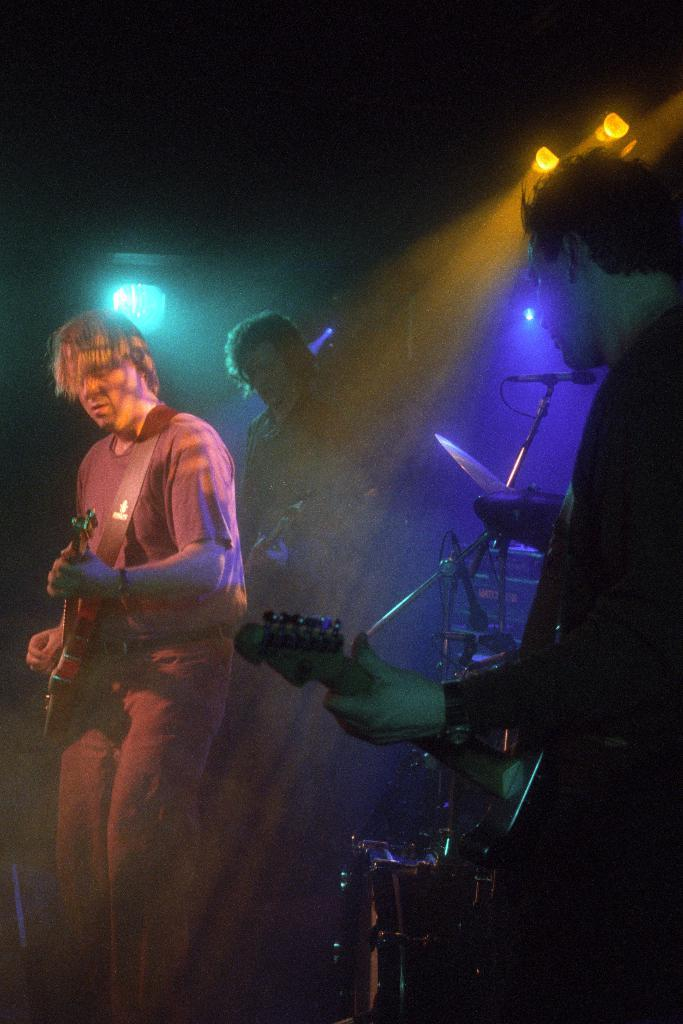How many people are in the image? There are people in the image, but the exact number is not specified. What are the people holding in the image? The people are holding guitars in the image. What day of the week is shown on the calendar in the image? There is no calendar present in the image, so it is not possible to determine the day of the week. 